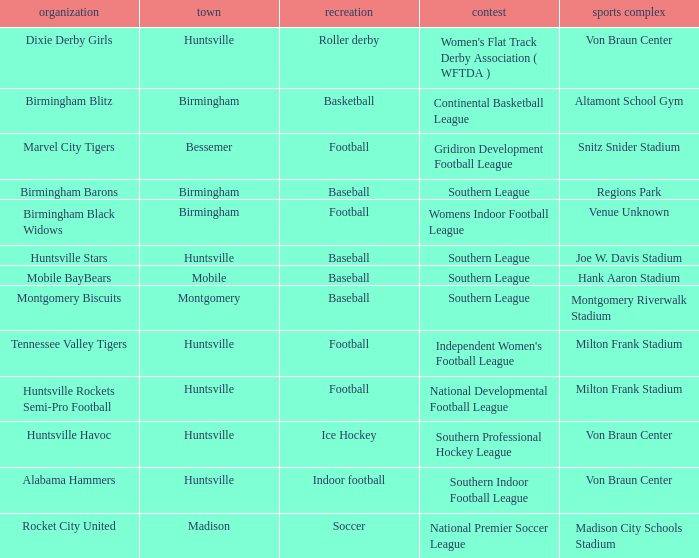Which venue hosted the Dixie Derby Girls? Von Braun Center. 